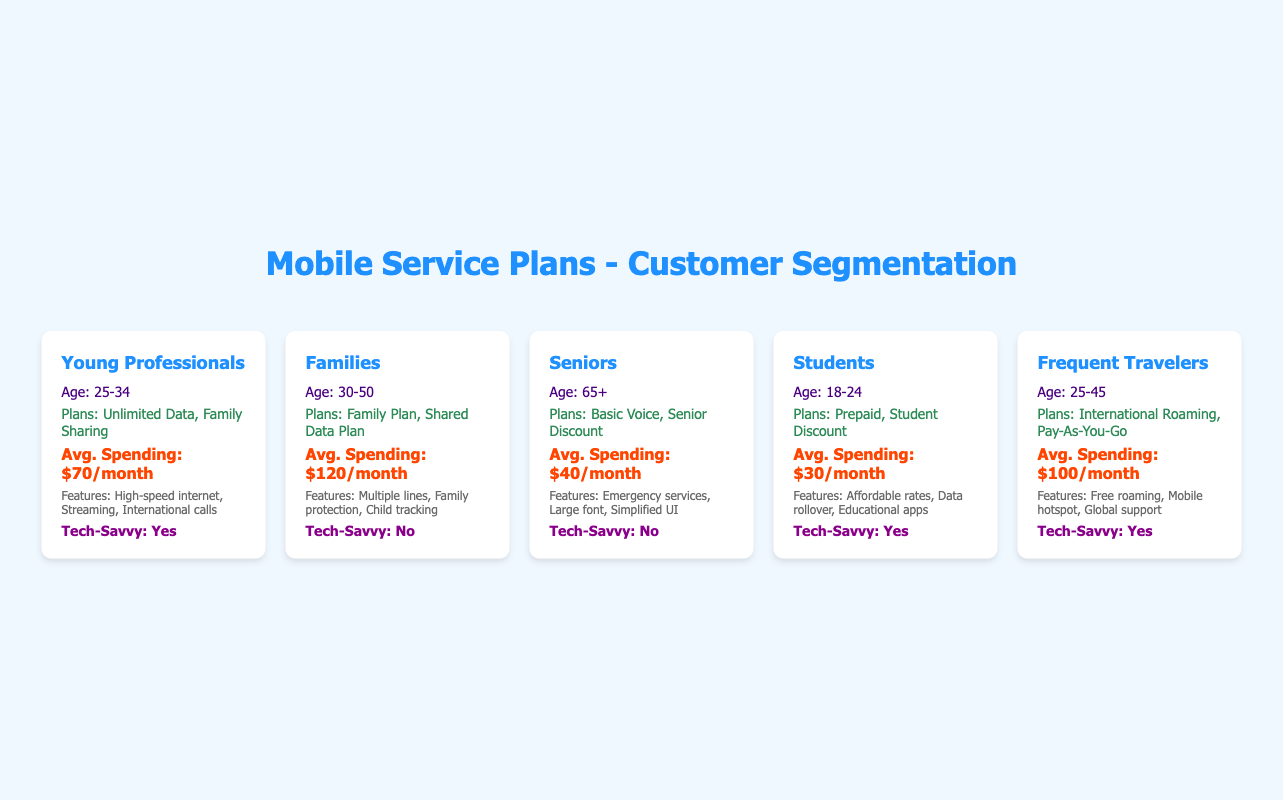What is the average monthly spending for Families? The average monthly spending for Families, as per the table, is listed directly as $120 per month.
Answer: 120 Which segment has the highest average monthly spending? By comparing the average monthly spending across all segments, we see that Families have the highest average at $120.
Answer: Families Are Young Professionals tech-savvy? The table indicates that Young Professionals are tech-savvy, as it specifically states "Tech-Savvy: Yes."
Answer: Yes What are the preferred plans for Students? The preferred plans for Students, according to the table, are "Prepaid Plan" and "Student Discount Plan."
Answer: Prepaid Plan, Student Discount Plan Calculate the total average monthly spending for all segments. The individual average spending amounts (70 + 120 + 40 + 30 + 100) total 360. With 5 segments, the average is 360/5 = 72.
Answer: 72 Which customer segment has the lowest average monthly spending? Examining the average monthly spending values, Seniors have the lowest at $40, making them the segment with the lowest spending.
Answer: Seniors Do Frequent Travelers prefer Basic Voice Plans? The data shows that Frequent Travelers prefer "International Roaming Plan" and "Pay-As-You-Go Plan," so they do not prefer Basic Voice Plans.
Answer: No What features are common among Families? The common features listed for Families include "Multiple lines," "Family protection services," and "Child tracking features."
Answer: Multiple lines, Family protection services, Child tracking features Is the Average Spending for Tech-Savvy customers higher than that of non-Tech-Savvy customers? The average spending for tech-savvy customers (Young Professionals, Students, Frequent Travelers) is (70 + 30 + 100)/3 = 66.67, while non-Tech-Savvy customers (Families, Seniors) average (120 + 40)/2 = 80. Since 66.67 is lower than 80, the statement is false.
Answer: No 